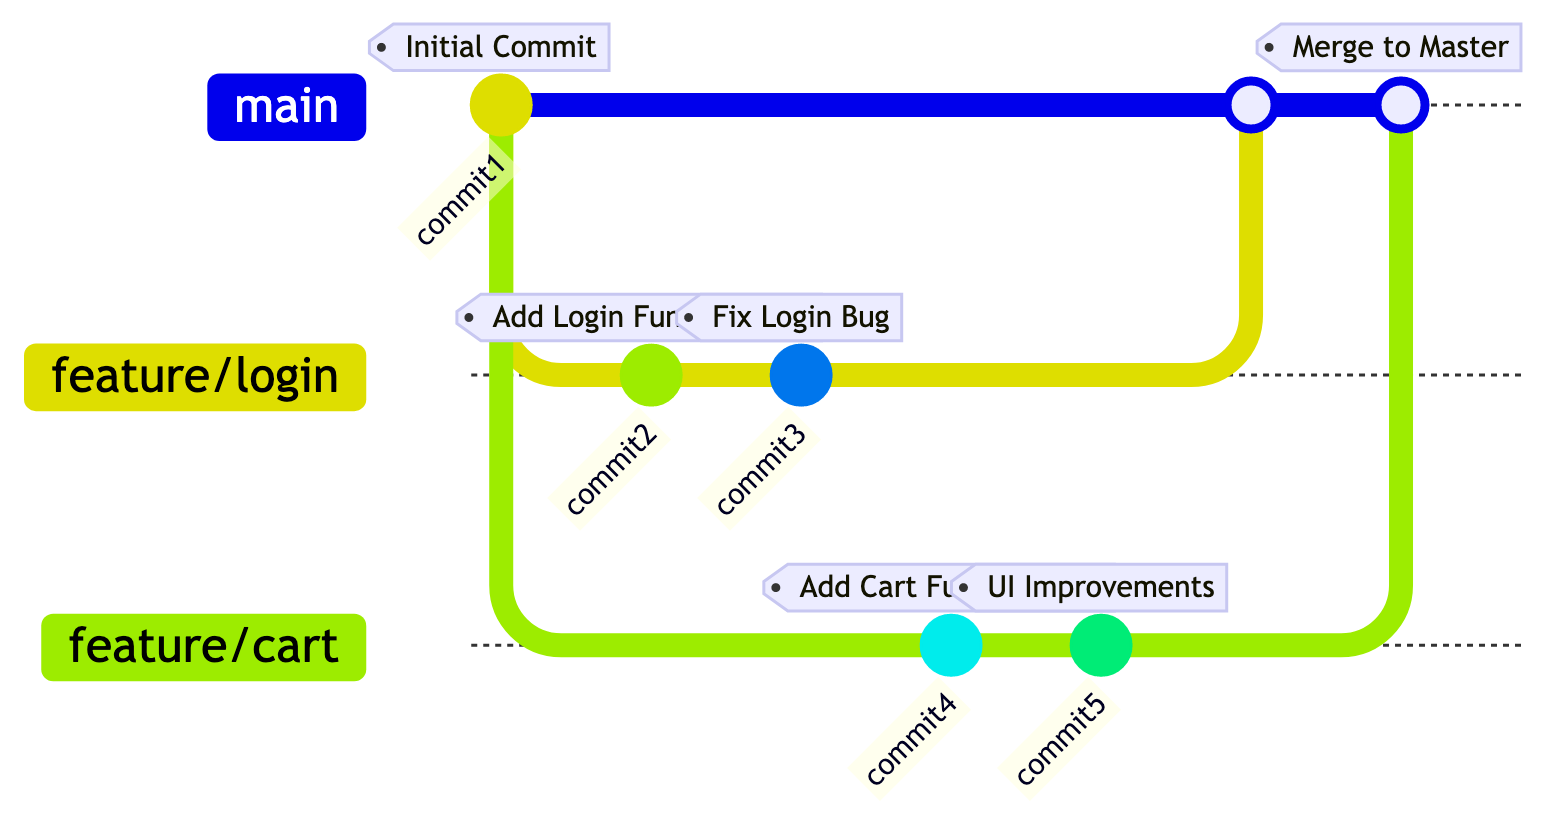What is the tag of the first commit? The diagram indicates that the first commit is tagged as "Initial Commit", which directly corresponds to the label associated with the first node.
Answer: Initial Commit How many branches are created in total? Scanning the diagram reveals two branches: "feature/login" and "feature/cart", making a total of two branches created in this workflow.
Answer: 2 What is the tag of the merge commit to the master? The diagram shows that when both feature branches are merged into the main branch, the merge commit is tagged as "Merge to Master".
Answer: Merge to Master Which branch contains the commits related to login functionality? The diagram clearly indicates that the "feature/login" branch is where the commits for login functionality are made, including the tags related to that feature.
Answer: feature/login Which commit added UI improvements? By examining the commits on the "feature/cart" branch, we can see that the commit that added UI improvements is marked as "UI Improvements".
Answer: UI Improvements What is the order of commits in the feature/login branch? The feature/login branch has two commits in the following order: "Add Login Functionality" follows "Initial Commit" and is followed by "Fix Login Bug". This sequence is directly evident in the branching structure.
Answer: Add Login Functionality, Fix Login Bug What happens after testing the login feature? After the commits on the "feature/login" branch (which includes testing and fixing login bug), the next step involves merging that branch into the main branch, as indicated in the workflow.
Answer: Merge feature/login Which branch was checked out before merging? According to the flow in the diagram, the branch checked out before merging into main is "feature/cart".
Answer: feature/cart 